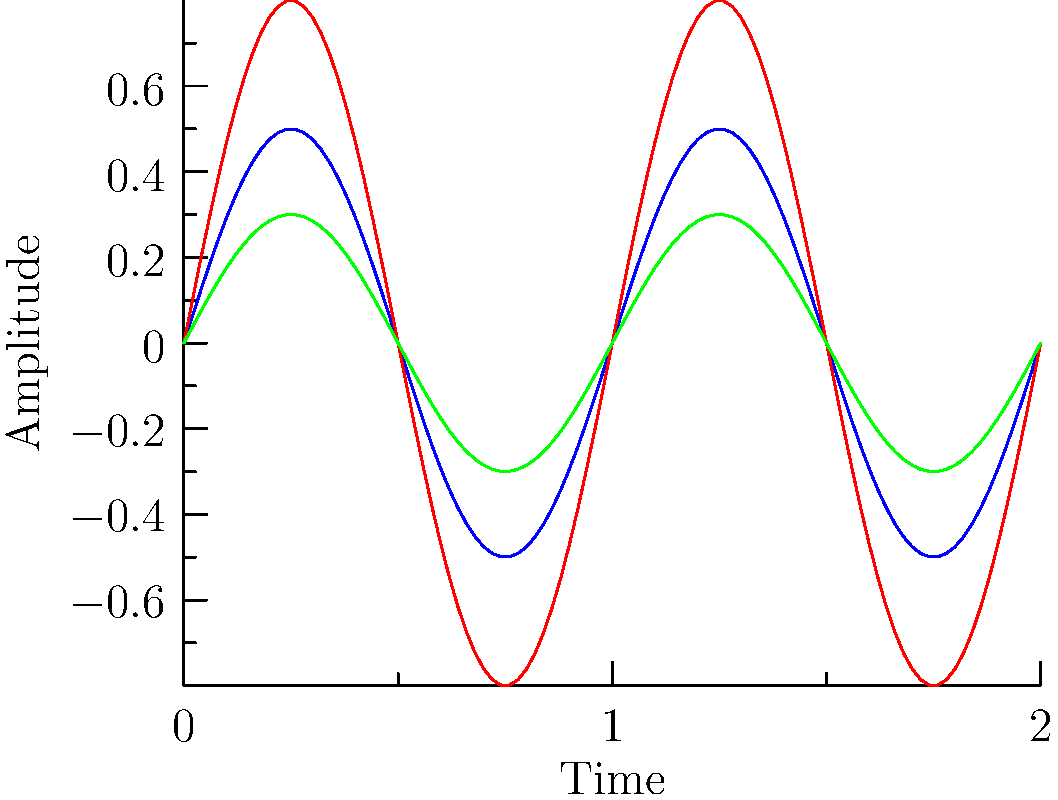Analyze the waveform diagrams representing different microphone placements for recording a kick drum. Which placement is likely to capture the most low-frequency content and why? To determine which microphone placement captures the most low-frequency content, we need to analyze the waveforms:

1. Blue waveform (Close overhead): 
   - Moderate amplitude
   - Relatively balanced frequency content

2. Red waveform (Room mic):
   - Highest amplitude
   - Captures overall room sound, including reflections

3. Green waveform (Inside kick drum):
   - Lowest amplitude
   - Tighter, more focused waveform

Low-frequency content is typically characterized by:
a) Lower amplitude (due to longer wavelengths)
b) More focused, less "spread out" waveform

The green waveform (Inside kick drum) exhibits these characteristics:
- It has the lowest amplitude, consistent with capturing more low-end
- The waveform is tighter and more focused, indicating less high-frequency content

Additionally, placing a microphone inside the kick drum physically positions it closest to the source of low-frequency vibrations, allowing it to capture these frequencies more directly and with less interference from other sound sources or room reflections.

Therefore, the microphone placement inside the kick drum is most likely to capture the most low-frequency content.
Answer: Inside kick drum placement 